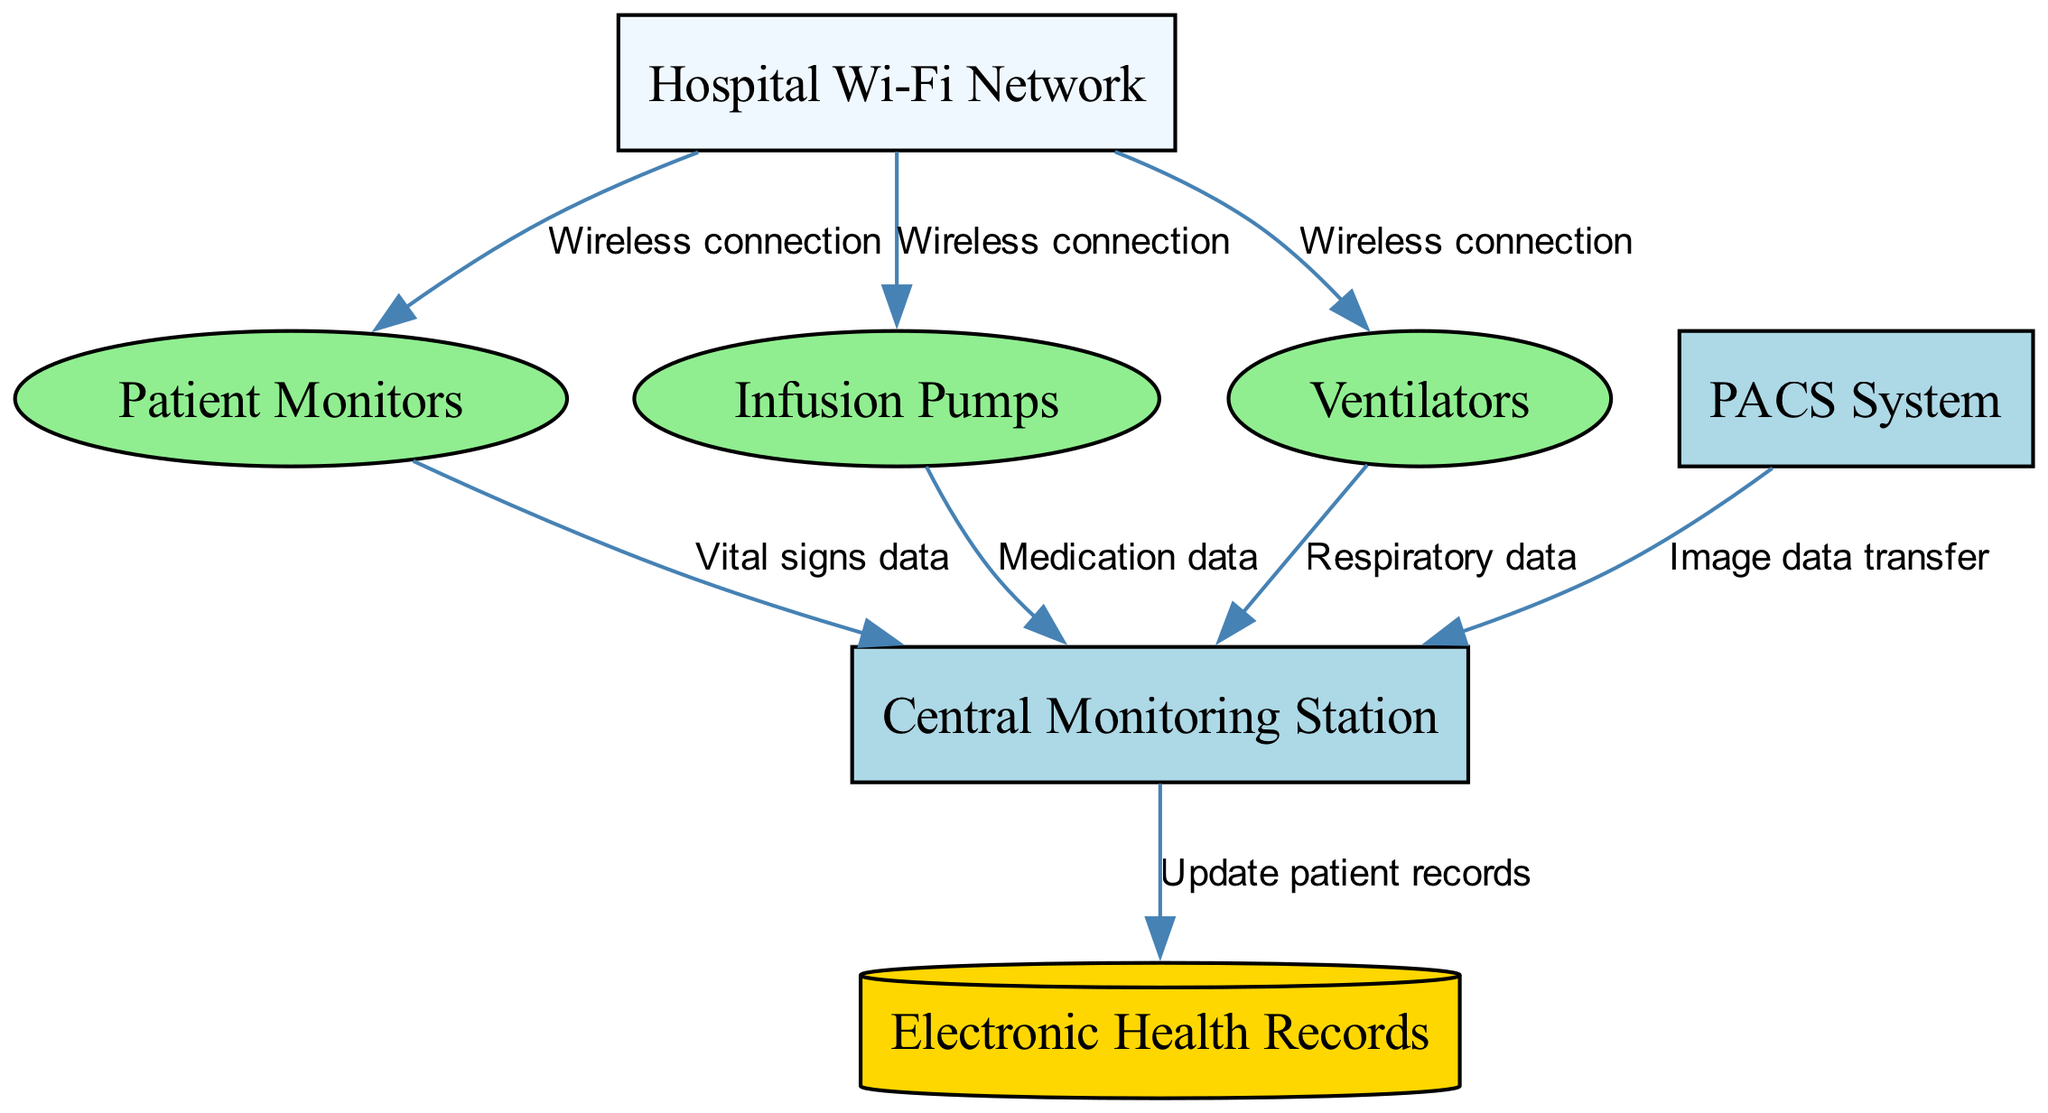What is the type of the "Central Monitoring Station"? The "Central Monitoring Station" is identified in the nodes list as a Server, which is explicitly stated in the provided data under "type."
Answer: Server How many medical devices are shown in the diagram? The diagram lists three medical devices: Patient Monitors, Infusion Pumps, and Ventilators. To find the answer, we count these entries in the "nodes" section.
Answer: 3 What data type do Patient Monitors send to the Central Monitoring Station? According to the edge connecting Patient Monitors to the Central Monitoring Station, the data type sent is "Vital signs data." This is labeled on the edge in the diagram data.
Answer: Vital signs data Which node receives image data? The "Central Monitoring Station" receives image data from the "PACS System," which is stated in the edge description between these two nodes.
Answer: Central Monitoring Station How many edges connect the Hospital Wi-Fi Network to medical devices? The Hospital Wi-Fi Network connects to three medical devices: Patient Monitors, Infusion Pumps, and Ventilators. This is verified by counting the edges starting from the Hospital Wi-Fi Network in the edges section.
Answer: 3 What type of connection is indicated between the Hospital Wi-Fi Network and medical devices? The connection between the Hospital Wi-Fi Network and each medical device is labeled as "Wireless connection." This is specified on each corresponding edge.
Answer: Wireless connection Which device transmits medication data to the Central Monitoring Station? The device that transmits medication data to the Central Monitoring Station is the Infusion Pumps, based on the edge description connecting them.
Answer: Infusion Pumps How many total nodes are present in the diagram? By counting all the entries in the "nodes" section, we find there are seven nodes listed in total.
Answer: 7 What is the type of the database used in the hospital ecosystem? The database in the diagram is called "Electronic Health Records," which is classified as a Database in the node list.
Answer: Electronic Health Records 